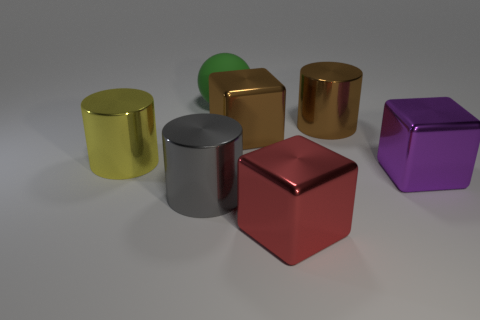Subtract all cyan spheres. Subtract all cyan cubes. How many spheres are left? 1 Add 2 big yellow objects. How many objects exist? 9 Subtract all blocks. How many objects are left? 4 Subtract 0 blue balls. How many objects are left? 7 Subtract all green objects. Subtract all large gray cylinders. How many objects are left? 5 Add 5 large gray shiny things. How many large gray shiny things are left? 6 Add 6 small green spheres. How many small green spheres exist? 6 